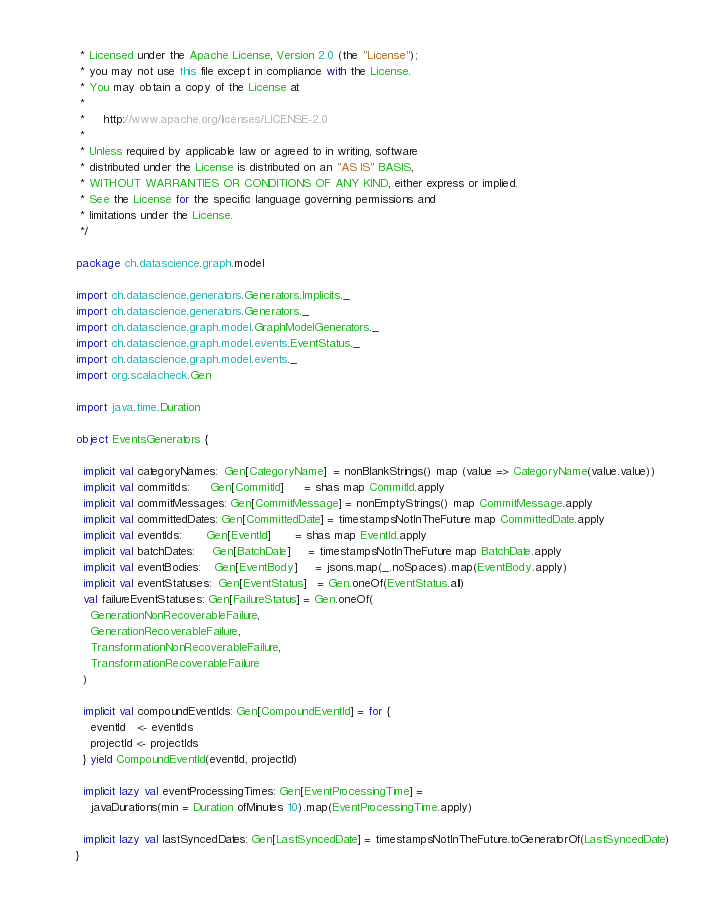Convert code to text. <code><loc_0><loc_0><loc_500><loc_500><_Scala_> * Licensed under the Apache License, Version 2.0 (the "License");
 * you may not use this file except in compliance with the License.
 * You may obtain a copy of the License at
 *
 *     http://www.apache.org/licenses/LICENSE-2.0
 *
 * Unless required by applicable law or agreed to in writing, software
 * distributed under the License is distributed on an "AS IS" BASIS,
 * WITHOUT WARRANTIES OR CONDITIONS OF ANY KIND, either express or implied.
 * See the License for the specific language governing permissions and
 * limitations under the License.
 */

package ch.datascience.graph.model

import ch.datascience.generators.Generators.Implicits._
import ch.datascience.generators.Generators._
import ch.datascience.graph.model.GraphModelGenerators._
import ch.datascience.graph.model.events.EventStatus._
import ch.datascience.graph.model.events._
import org.scalacheck.Gen

import java.time.Duration

object EventsGenerators {

  implicit val categoryNames:  Gen[CategoryName]  = nonBlankStrings() map (value => CategoryName(value.value))
  implicit val commitIds:      Gen[CommitId]      = shas map CommitId.apply
  implicit val commitMessages: Gen[CommitMessage] = nonEmptyStrings() map CommitMessage.apply
  implicit val committedDates: Gen[CommittedDate] = timestampsNotInTheFuture map CommittedDate.apply
  implicit val eventIds:       Gen[EventId]       = shas map EventId.apply
  implicit val batchDates:     Gen[BatchDate]     = timestampsNotInTheFuture map BatchDate.apply
  implicit val eventBodies:    Gen[EventBody]     = jsons.map(_.noSpaces).map(EventBody.apply)
  implicit val eventStatuses:  Gen[EventStatus]   = Gen.oneOf(EventStatus.all)
  val failureEventStatuses: Gen[FailureStatus] = Gen.oneOf(
    GenerationNonRecoverableFailure,
    GenerationRecoverableFailure,
    TransformationNonRecoverableFailure,
    TransformationRecoverableFailure
  )

  implicit val compoundEventIds: Gen[CompoundEventId] = for {
    eventId   <- eventIds
    projectId <- projectIds
  } yield CompoundEventId(eventId, projectId)

  implicit lazy val eventProcessingTimes: Gen[EventProcessingTime] =
    javaDurations(min = Duration ofMinutes 10).map(EventProcessingTime.apply)

  implicit lazy val lastSyncedDates: Gen[LastSyncedDate] = timestampsNotInTheFuture.toGeneratorOf(LastSyncedDate)
}
</code> 